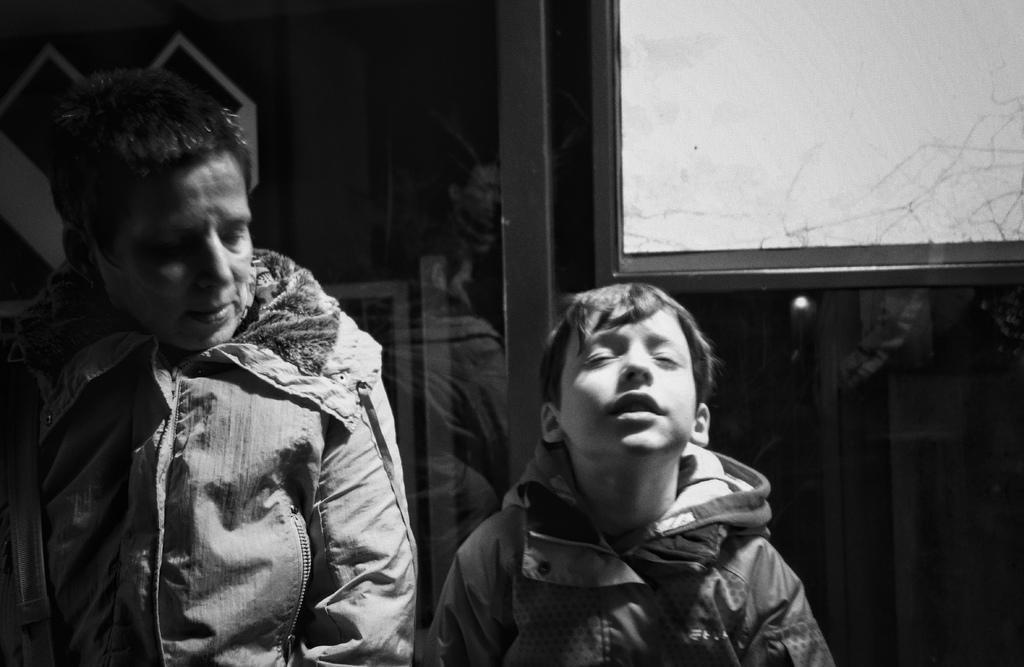Please provide a concise description of this image. This is a black and white image. Behind the two persons, I can see the reflection of people and there is a board. 